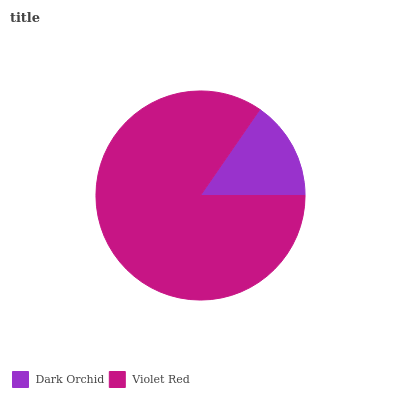Is Dark Orchid the minimum?
Answer yes or no. Yes. Is Violet Red the maximum?
Answer yes or no. Yes. Is Violet Red the minimum?
Answer yes or no. No. Is Violet Red greater than Dark Orchid?
Answer yes or no. Yes. Is Dark Orchid less than Violet Red?
Answer yes or no. Yes. Is Dark Orchid greater than Violet Red?
Answer yes or no. No. Is Violet Red less than Dark Orchid?
Answer yes or no. No. Is Violet Red the high median?
Answer yes or no. Yes. Is Dark Orchid the low median?
Answer yes or no. Yes. Is Dark Orchid the high median?
Answer yes or no. No. Is Violet Red the low median?
Answer yes or no. No. 